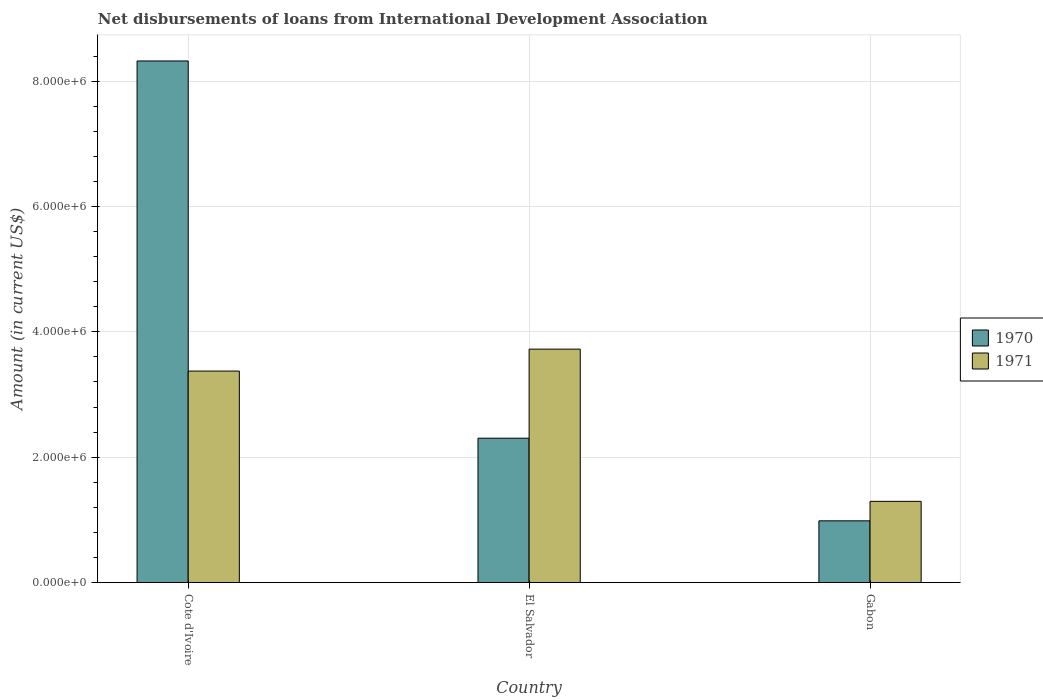How many groups of bars are there?
Provide a succinct answer. 3. How many bars are there on the 2nd tick from the left?
Provide a short and direct response. 2. What is the label of the 2nd group of bars from the left?
Offer a very short reply. El Salvador. What is the amount of loans disbursed in 1970 in Cote d'Ivoire?
Your answer should be very brief. 8.32e+06. Across all countries, what is the maximum amount of loans disbursed in 1971?
Keep it short and to the point. 3.72e+06. Across all countries, what is the minimum amount of loans disbursed in 1971?
Your answer should be very brief. 1.30e+06. In which country was the amount of loans disbursed in 1971 maximum?
Offer a terse response. El Salvador. In which country was the amount of loans disbursed in 1970 minimum?
Your answer should be very brief. Gabon. What is the total amount of loans disbursed in 1970 in the graph?
Your answer should be very brief. 1.16e+07. What is the difference between the amount of loans disbursed in 1970 in Cote d'Ivoire and that in El Salvador?
Keep it short and to the point. 6.02e+06. What is the difference between the amount of loans disbursed in 1970 in El Salvador and the amount of loans disbursed in 1971 in Gabon?
Ensure brevity in your answer.  1.01e+06. What is the average amount of loans disbursed in 1970 per country?
Offer a very short reply. 3.87e+06. What is the difference between the amount of loans disbursed of/in 1970 and amount of loans disbursed of/in 1971 in Gabon?
Offer a very short reply. -3.11e+05. What is the ratio of the amount of loans disbursed in 1970 in Cote d'Ivoire to that in El Salvador?
Provide a short and direct response. 3.61. Is the amount of loans disbursed in 1971 in El Salvador less than that in Gabon?
Keep it short and to the point. No. Is the difference between the amount of loans disbursed in 1970 in Cote d'Ivoire and El Salvador greater than the difference between the amount of loans disbursed in 1971 in Cote d'Ivoire and El Salvador?
Your response must be concise. Yes. What is the difference between the highest and the second highest amount of loans disbursed in 1971?
Your answer should be compact. 2.43e+06. What is the difference between the highest and the lowest amount of loans disbursed in 1971?
Give a very brief answer. 2.43e+06. What does the 2nd bar from the left in Cote d'Ivoire represents?
Make the answer very short. 1971. How many bars are there?
Provide a succinct answer. 6. Are all the bars in the graph horizontal?
Keep it short and to the point. No. Are the values on the major ticks of Y-axis written in scientific E-notation?
Your answer should be very brief. Yes. Does the graph contain any zero values?
Keep it short and to the point. No. Does the graph contain grids?
Give a very brief answer. Yes. How are the legend labels stacked?
Ensure brevity in your answer.  Vertical. What is the title of the graph?
Offer a very short reply. Net disbursements of loans from International Development Association. What is the Amount (in current US$) of 1970 in Cote d'Ivoire?
Make the answer very short. 8.32e+06. What is the Amount (in current US$) of 1971 in Cote d'Ivoire?
Make the answer very short. 3.37e+06. What is the Amount (in current US$) of 1970 in El Salvador?
Ensure brevity in your answer.  2.30e+06. What is the Amount (in current US$) of 1971 in El Salvador?
Keep it short and to the point. 3.72e+06. What is the Amount (in current US$) of 1970 in Gabon?
Your answer should be compact. 9.85e+05. What is the Amount (in current US$) of 1971 in Gabon?
Your answer should be very brief. 1.30e+06. Across all countries, what is the maximum Amount (in current US$) in 1970?
Offer a very short reply. 8.32e+06. Across all countries, what is the maximum Amount (in current US$) in 1971?
Your response must be concise. 3.72e+06. Across all countries, what is the minimum Amount (in current US$) of 1970?
Give a very brief answer. 9.85e+05. Across all countries, what is the minimum Amount (in current US$) of 1971?
Provide a short and direct response. 1.30e+06. What is the total Amount (in current US$) in 1970 in the graph?
Ensure brevity in your answer.  1.16e+07. What is the total Amount (in current US$) in 1971 in the graph?
Your answer should be compact. 8.39e+06. What is the difference between the Amount (in current US$) in 1970 in Cote d'Ivoire and that in El Salvador?
Your answer should be compact. 6.02e+06. What is the difference between the Amount (in current US$) of 1971 in Cote d'Ivoire and that in El Salvador?
Offer a terse response. -3.50e+05. What is the difference between the Amount (in current US$) in 1970 in Cote d'Ivoire and that in Gabon?
Ensure brevity in your answer.  7.34e+06. What is the difference between the Amount (in current US$) of 1971 in Cote d'Ivoire and that in Gabon?
Provide a short and direct response. 2.08e+06. What is the difference between the Amount (in current US$) in 1970 in El Salvador and that in Gabon?
Your response must be concise. 1.32e+06. What is the difference between the Amount (in current US$) of 1971 in El Salvador and that in Gabon?
Your answer should be compact. 2.43e+06. What is the difference between the Amount (in current US$) in 1970 in Cote d'Ivoire and the Amount (in current US$) in 1971 in El Salvador?
Provide a short and direct response. 4.60e+06. What is the difference between the Amount (in current US$) of 1970 in Cote d'Ivoire and the Amount (in current US$) of 1971 in Gabon?
Your answer should be very brief. 7.02e+06. What is the difference between the Amount (in current US$) in 1970 in El Salvador and the Amount (in current US$) in 1971 in Gabon?
Provide a succinct answer. 1.01e+06. What is the average Amount (in current US$) in 1970 per country?
Keep it short and to the point. 3.87e+06. What is the average Amount (in current US$) in 1971 per country?
Your answer should be compact. 2.80e+06. What is the difference between the Amount (in current US$) of 1970 and Amount (in current US$) of 1971 in Cote d'Ivoire?
Your answer should be very brief. 4.95e+06. What is the difference between the Amount (in current US$) of 1970 and Amount (in current US$) of 1971 in El Salvador?
Ensure brevity in your answer.  -1.42e+06. What is the difference between the Amount (in current US$) of 1970 and Amount (in current US$) of 1971 in Gabon?
Offer a very short reply. -3.11e+05. What is the ratio of the Amount (in current US$) in 1970 in Cote d'Ivoire to that in El Salvador?
Ensure brevity in your answer.  3.61. What is the ratio of the Amount (in current US$) in 1971 in Cote d'Ivoire to that in El Salvador?
Keep it short and to the point. 0.91. What is the ratio of the Amount (in current US$) of 1970 in Cote d'Ivoire to that in Gabon?
Provide a succinct answer. 8.45. What is the ratio of the Amount (in current US$) in 1971 in Cote d'Ivoire to that in Gabon?
Your response must be concise. 2.6. What is the ratio of the Amount (in current US$) of 1970 in El Salvador to that in Gabon?
Your answer should be compact. 2.34. What is the ratio of the Amount (in current US$) in 1971 in El Salvador to that in Gabon?
Ensure brevity in your answer.  2.87. What is the difference between the highest and the second highest Amount (in current US$) in 1970?
Offer a terse response. 6.02e+06. What is the difference between the highest and the second highest Amount (in current US$) of 1971?
Your answer should be compact. 3.50e+05. What is the difference between the highest and the lowest Amount (in current US$) in 1970?
Offer a terse response. 7.34e+06. What is the difference between the highest and the lowest Amount (in current US$) of 1971?
Keep it short and to the point. 2.43e+06. 